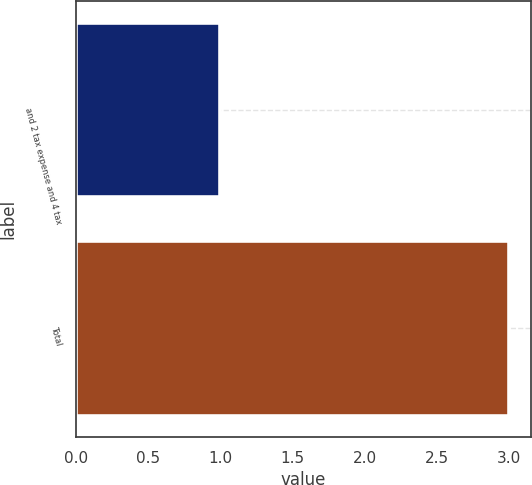<chart> <loc_0><loc_0><loc_500><loc_500><bar_chart><fcel>and 2 tax expense and 4 tax<fcel>Total<nl><fcel>1<fcel>3<nl></chart> 